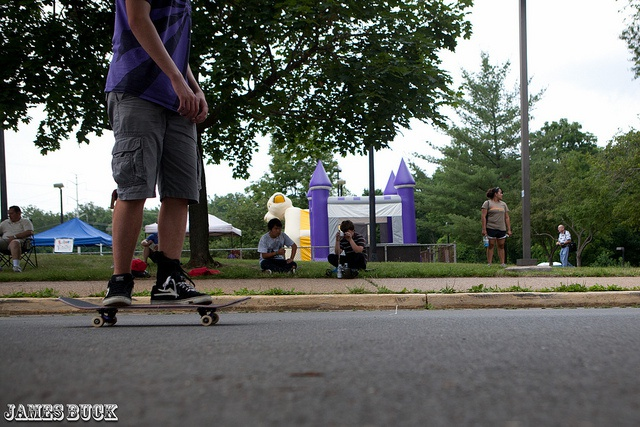Describe the objects in this image and their specific colors. I can see people in black, maroon, gray, and navy tones, skateboard in black and gray tones, people in black, gray, and maroon tones, people in black, gray, and maroon tones, and people in black and gray tones in this image. 